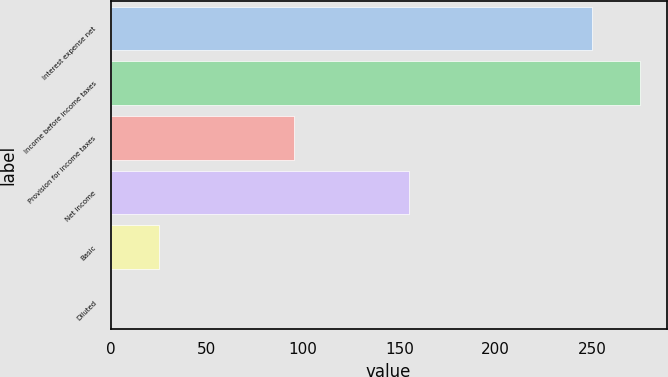Convert chart to OTSL. <chart><loc_0><loc_0><loc_500><loc_500><bar_chart><fcel>Interest expense net<fcel>Income before income taxes<fcel>Provision for income taxes<fcel>Net income<fcel>Basic<fcel>Diluted<nl><fcel>250<fcel>274.99<fcel>95<fcel>155<fcel>25.13<fcel>0.15<nl></chart> 